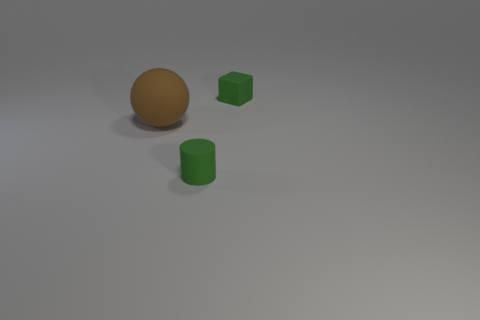What is the color of the rubber block?
Offer a very short reply. Green. There is a tiny green rubber object that is in front of the brown thing; does it have the same shape as the brown rubber object?
Your response must be concise. No. What is the shape of the small rubber object that is right of the green rubber thing in front of the green object behind the large object?
Ensure brevity in your answer.  Cube. There is a thing that is to the right of the green matte cylinder; what is its material?
Provide a short and direct response. Rubber. There is a matte object that is the same size as the cylinder; what color is it?
Provide a short and direct response. Green. What number of other objects are the same shape as the large object?
Provide a short and direct response. 0. Do the brown sphere and the green cylinder have the same size?
Your answer should be very brief. No. Is the number of tiny things in front of the tiny green rubber block greater than the number of balls that are to the right of the brown ball?
Your response must be concise. Yes. How many other objects are there of the same size as the rubber cube?
Offer a terse response. 1. There is a tiny matte thing that is behind the brown rubber object; is its color the same as the rubber cylinder?
Provide a succinct answer. Yes. 